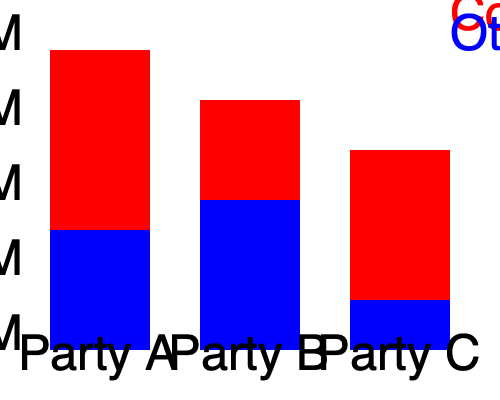The stacked bar graph shows corporate campaign contributions to three political parties. Which party received the highest percentage of its total contributions from Corporation X, and what potential concerns might this raise for public trust? To answer this question, we need to analyze the data for each party:

1. Party A:
   - Total height: 300 units
   - Corp X contribution (red): 180 units
   - Percentage from Corp X: $(180/300) * 100 = 60\%$

2. Party B:
   - Total height: 250 units
   - Corp X contribution (red): 100 units
   - Percentage from Corp X: $(100/250) * 100 = 40\%$

3. Party C:
   - Total height: 200 units
   - Corp X contribution (red): 150 units
   - Percentage from Corp X: $(150/200) * 100 = 75\%$

Party C received the highest percentage (75%) of its total contributions from Corporation X.

Potential concerns for public trust:
1. Undue influence: Corp X may have significant sway over Party C's policies and decisions.
2. Conflict of interest: Party C might prioritize Corp X's interests over public interests.
3. Lack of diverse representation: Other constituents and interests may be underrepresented.
4. Transparency issues: The public may question the motives behind such large contributions.
5. Policy bias: Legislation and regulations might be skewed to benefit Corp X.

These concerns could lead to decreased public trust in the political system and raise questions about the integrity of campaign finance practices.
Answer: Party C (75%); raises concerns about undue corporate influence, conflicts of interest, and policy bias. 